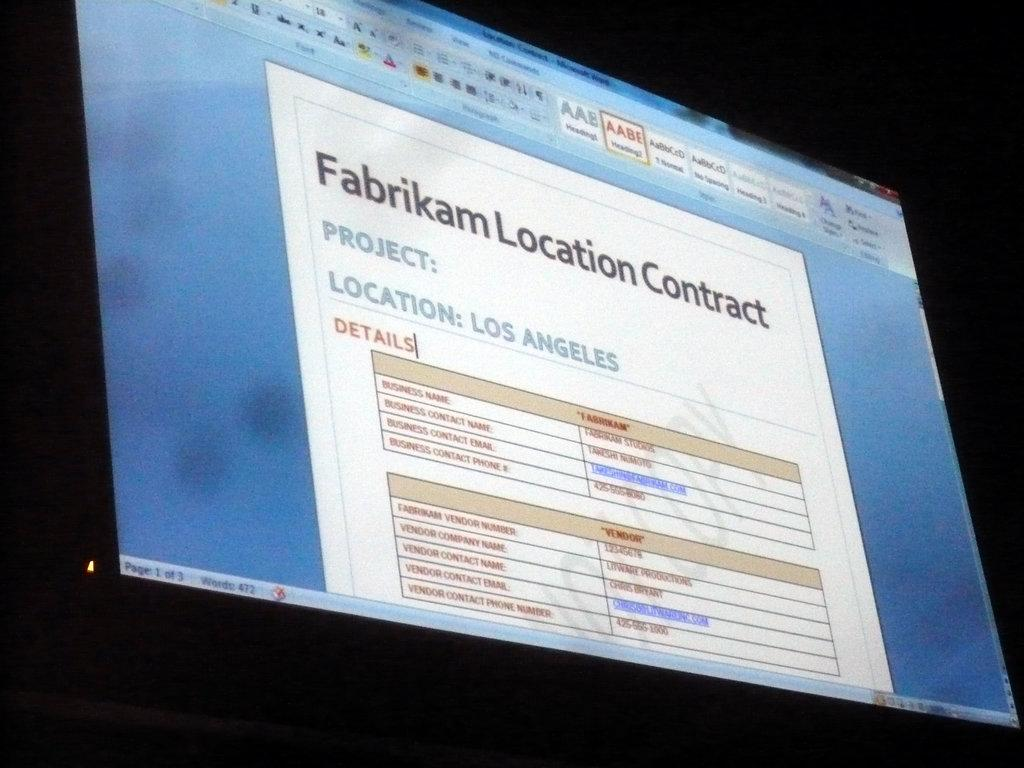<image>
Write a terse but informative summary of the picture. A computer screen shows information about a location contract. 